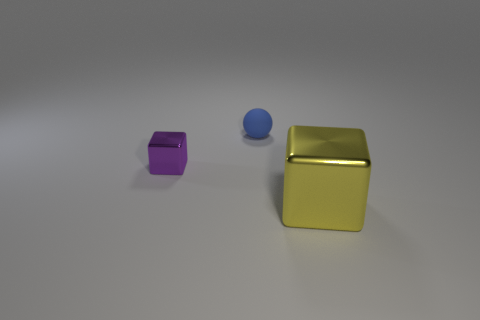Add 2 tiny matte balls. How many objects exist? 5 Subtract all cubes. How many objects are left? 1 Add 3 large matte cylinders. How many large matte cylinders exist? 3 Subtract 0 purple spheres. How many objects are left? 3 Subtract all large yellow blocks. Subtract all brown metal blocks. How many objects are left? 2 Add 3 large shiny blocks. How many large shiny blocks are left? 4 